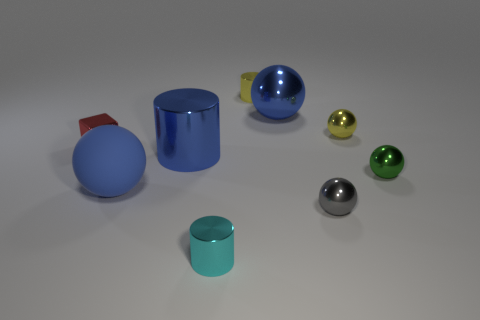What is the color of the block that is the same material as the large cylinder?
Offer a terse response. Red. Does the tiny cylinder behind the cyan metallic cylinder have the same material as the small thing that is in front of the gray object?
Provide a succinct answer. Yes. There is a metallic ball that is the same color as the large cylinder; what size is it?
Offer a very short reply. Large. What is the material of the tiny ball that is in front of the rubber thing?
Provide a short and direct response. Metal. There is a blue metal thing that is in front of the small red shiny thing; does it have the same shape as the big object in front of the green shiny sphere?
Offer a very short reply. No. What is the material of the ball that is the same color as the matte thing?
Make the answer very short. Metal. Is there a large red block?
Your answer should be compact. No. There is another green object that is the same shape as the rubber object; what material is it?
Your response must be concise. Metal. Are there any tiny green shiny balls to the left of the red cube?
Provide a short and direct response. No. Does the large ball that is behind the red cube have the same material as the small gray thing?
Your answer should be very brief. Yes. 